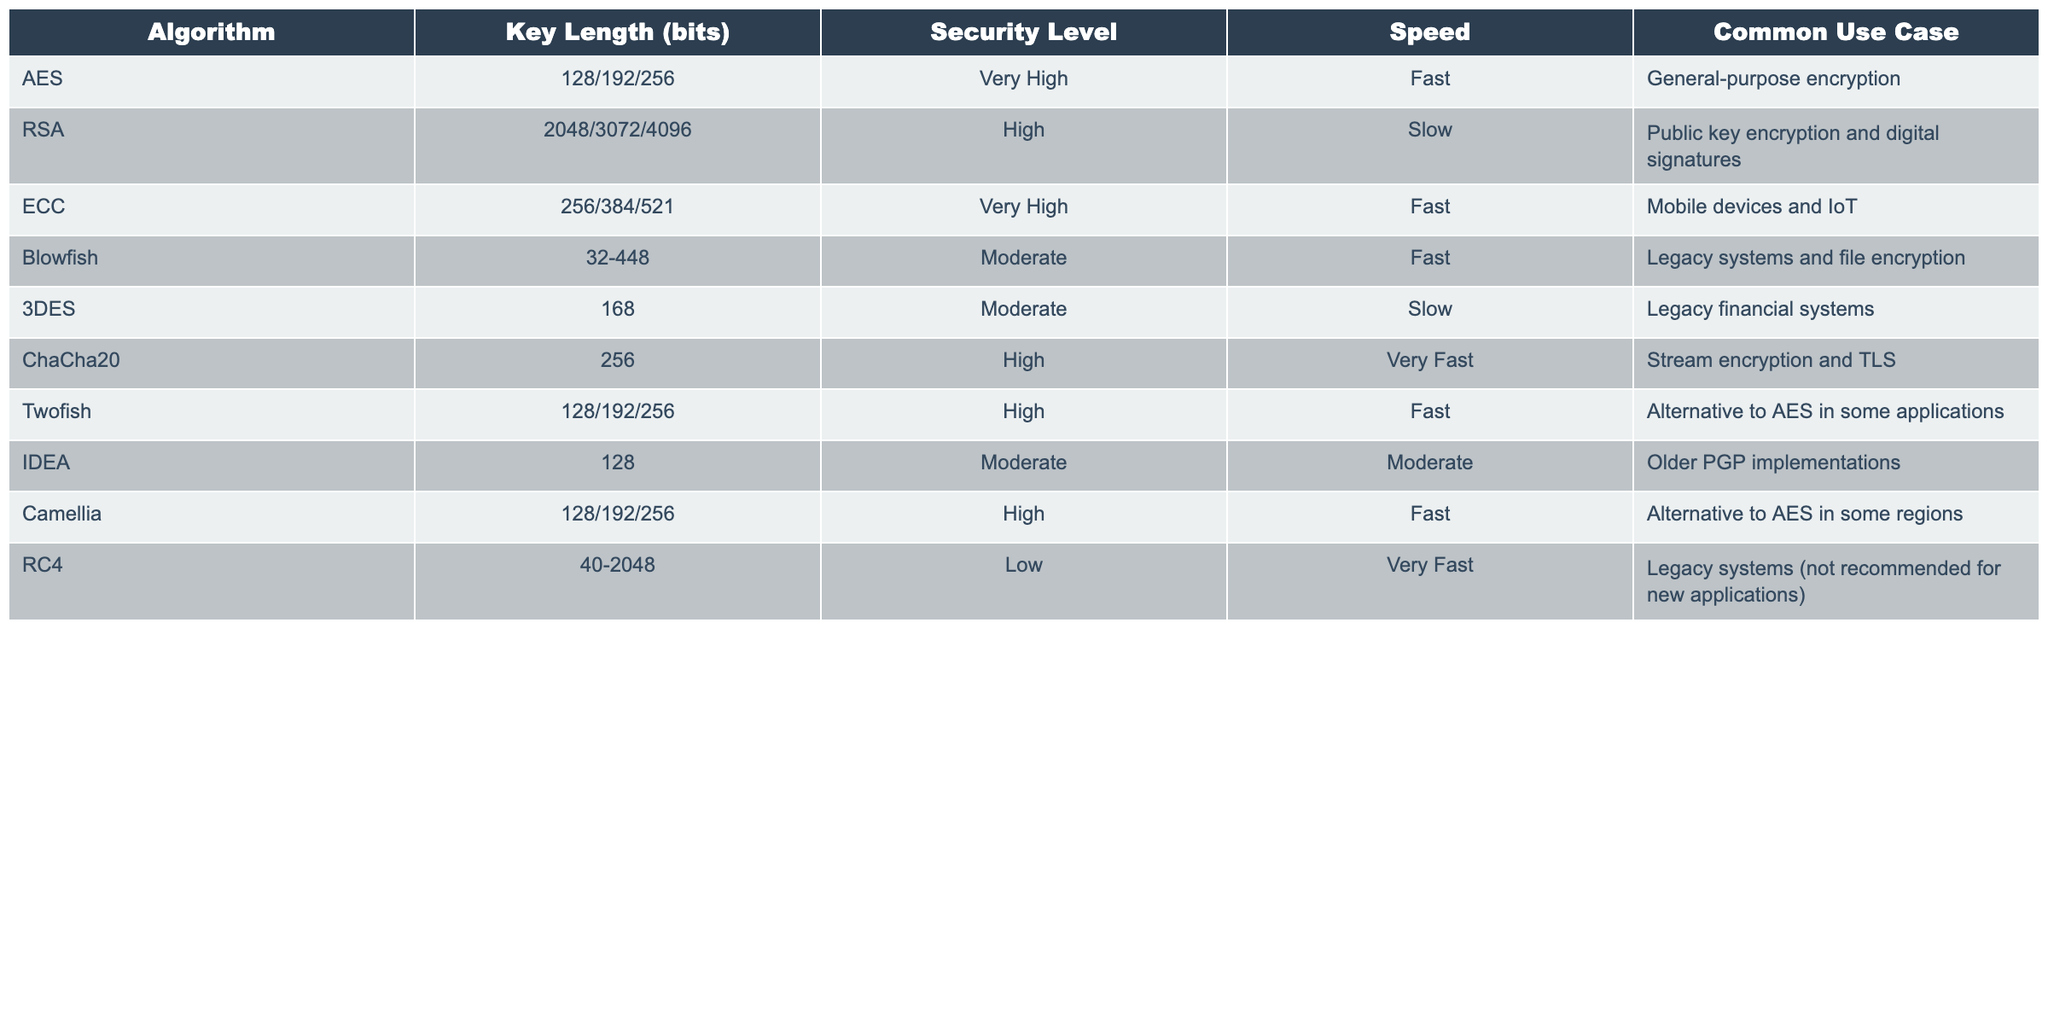What is the key length of AES? The table shows that AES has key lengths of 128, 192, and 256 bits.
Answer: 128/192/256 Is ChaCha20 considered a fast encryption algorithm? The table lists ChaCha20's speed as "Very Fast," confirming it is indeed a fast encryption algorithm.
Answer: Yes Which algorithm has the highest key length, and what is that length? According to the table, RSA can have a key length of 4096 bits, which is the highest among the listed algorithms.
Answer: RSA, 4096 bits What is the security level of Blowfish? The table indicates that Blowfish has a security level classified as "Moderate."
Answer: Moderate Are there more algorithms with a "Very High" security level than those with a "Low" security level? The table shows three algorithms (AES, ECC) with "Very High" security and one algorithm (RC4) with "Low" security, indicating that there are more algorithms with "Very High" security.
Answer: Yes What is the average key length of algorithms that use a key length of 128 bits? The algorithms that use a key length of 128 bits are AES, Twofish, Camellia, and IDEA. The average is calculated as follows: (128 + 128 + 128 + 128) / 4 = 128.
Answer: 128 Which encryption algorithm is best suited for mobile devices and IoT? The table specifies that ECC is the encryption algorithm best suited for mobile devices and IoT.
Answer: ECC Is RSA faster than 3DES? The table indicates that RSA is classified as "Slow" and 3DES is also "Slow," but since RSA's speed is noted as being slower than many, it can be inferred that 3DES's speed is relatively higher.
Answer: No What are the common use cases for Twofish? The table states that Twofish is used as an alternative to AES in some applications.
Answer: Alternative to AES Which encryption algorithm should not be recommended for new applications? The table specifies that RC4 is a legacy system and is not recommended for new applications.
Answer: RC4 